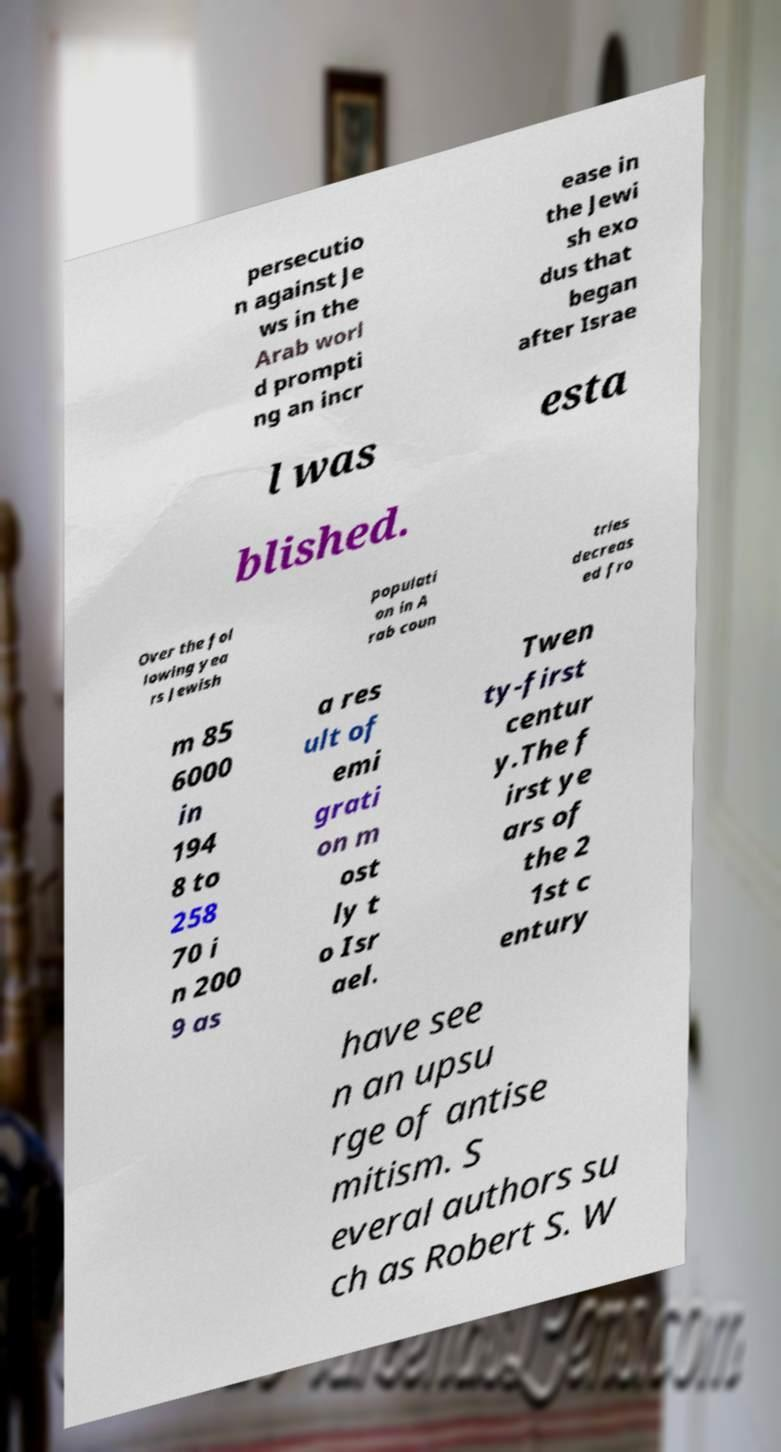Could you extract and type out the text from this image? persecutio n against Je ws in the Arab worl d prompti ng an incr ease in the Jewi sh exo dus that began after Israe l was esta blished. Over the fol lowing yea rs Jewish populati on in A rab coun tries decreas ed fro m 85 6000 in 194 8 to 258 70 i n 200 9 as a res ult of emi grati on m ost ly t o Isr ael. Twen ty-first centur y.The f irst ye ars of the 2 1st c entury have see n an upsu rge of antise mitism. S everal authors su ch as Robert S. W 